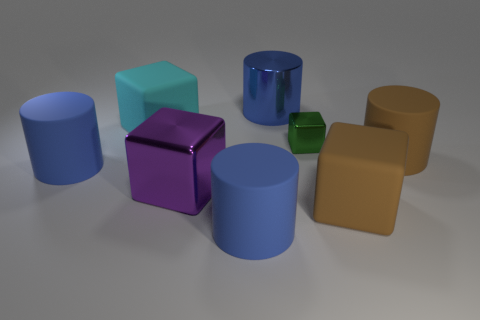Subtract all large cyan cubes. How many cubes are left? 3 Subtract all green blocks. How many blue cylinders are left? 3 Add 2 blue blocks. How many objects exist? 10 Subtract all brown cylinders. How many cylinders are left? 3 Subtract 1 cylinders. How many cylinders are left? 3 Subtract all red cylinders. Subtract all cyan blocks. How many cylinders are left? 4 Subtract 1 purple cubes. How many objects are left? 7 Subtract all large matte objects. Subtract all big blue things. How many objects are left? 0 Add 1 cyan cubes. How many cyan cubes are left? 2 Add 5 small cubes. How many small cubes exist? 6 